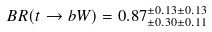Convert formula to latex. <formula><loc_0><loc_0><loc_500><loc_500>B R ( t \rightarrow b W ) = 0 . 8 7 ^ { \pm 0 . 1 3 \pm 0 . 1 3 } _ { \pm 0 . 3 0 \pm 0 . 1 1 }</formula> 